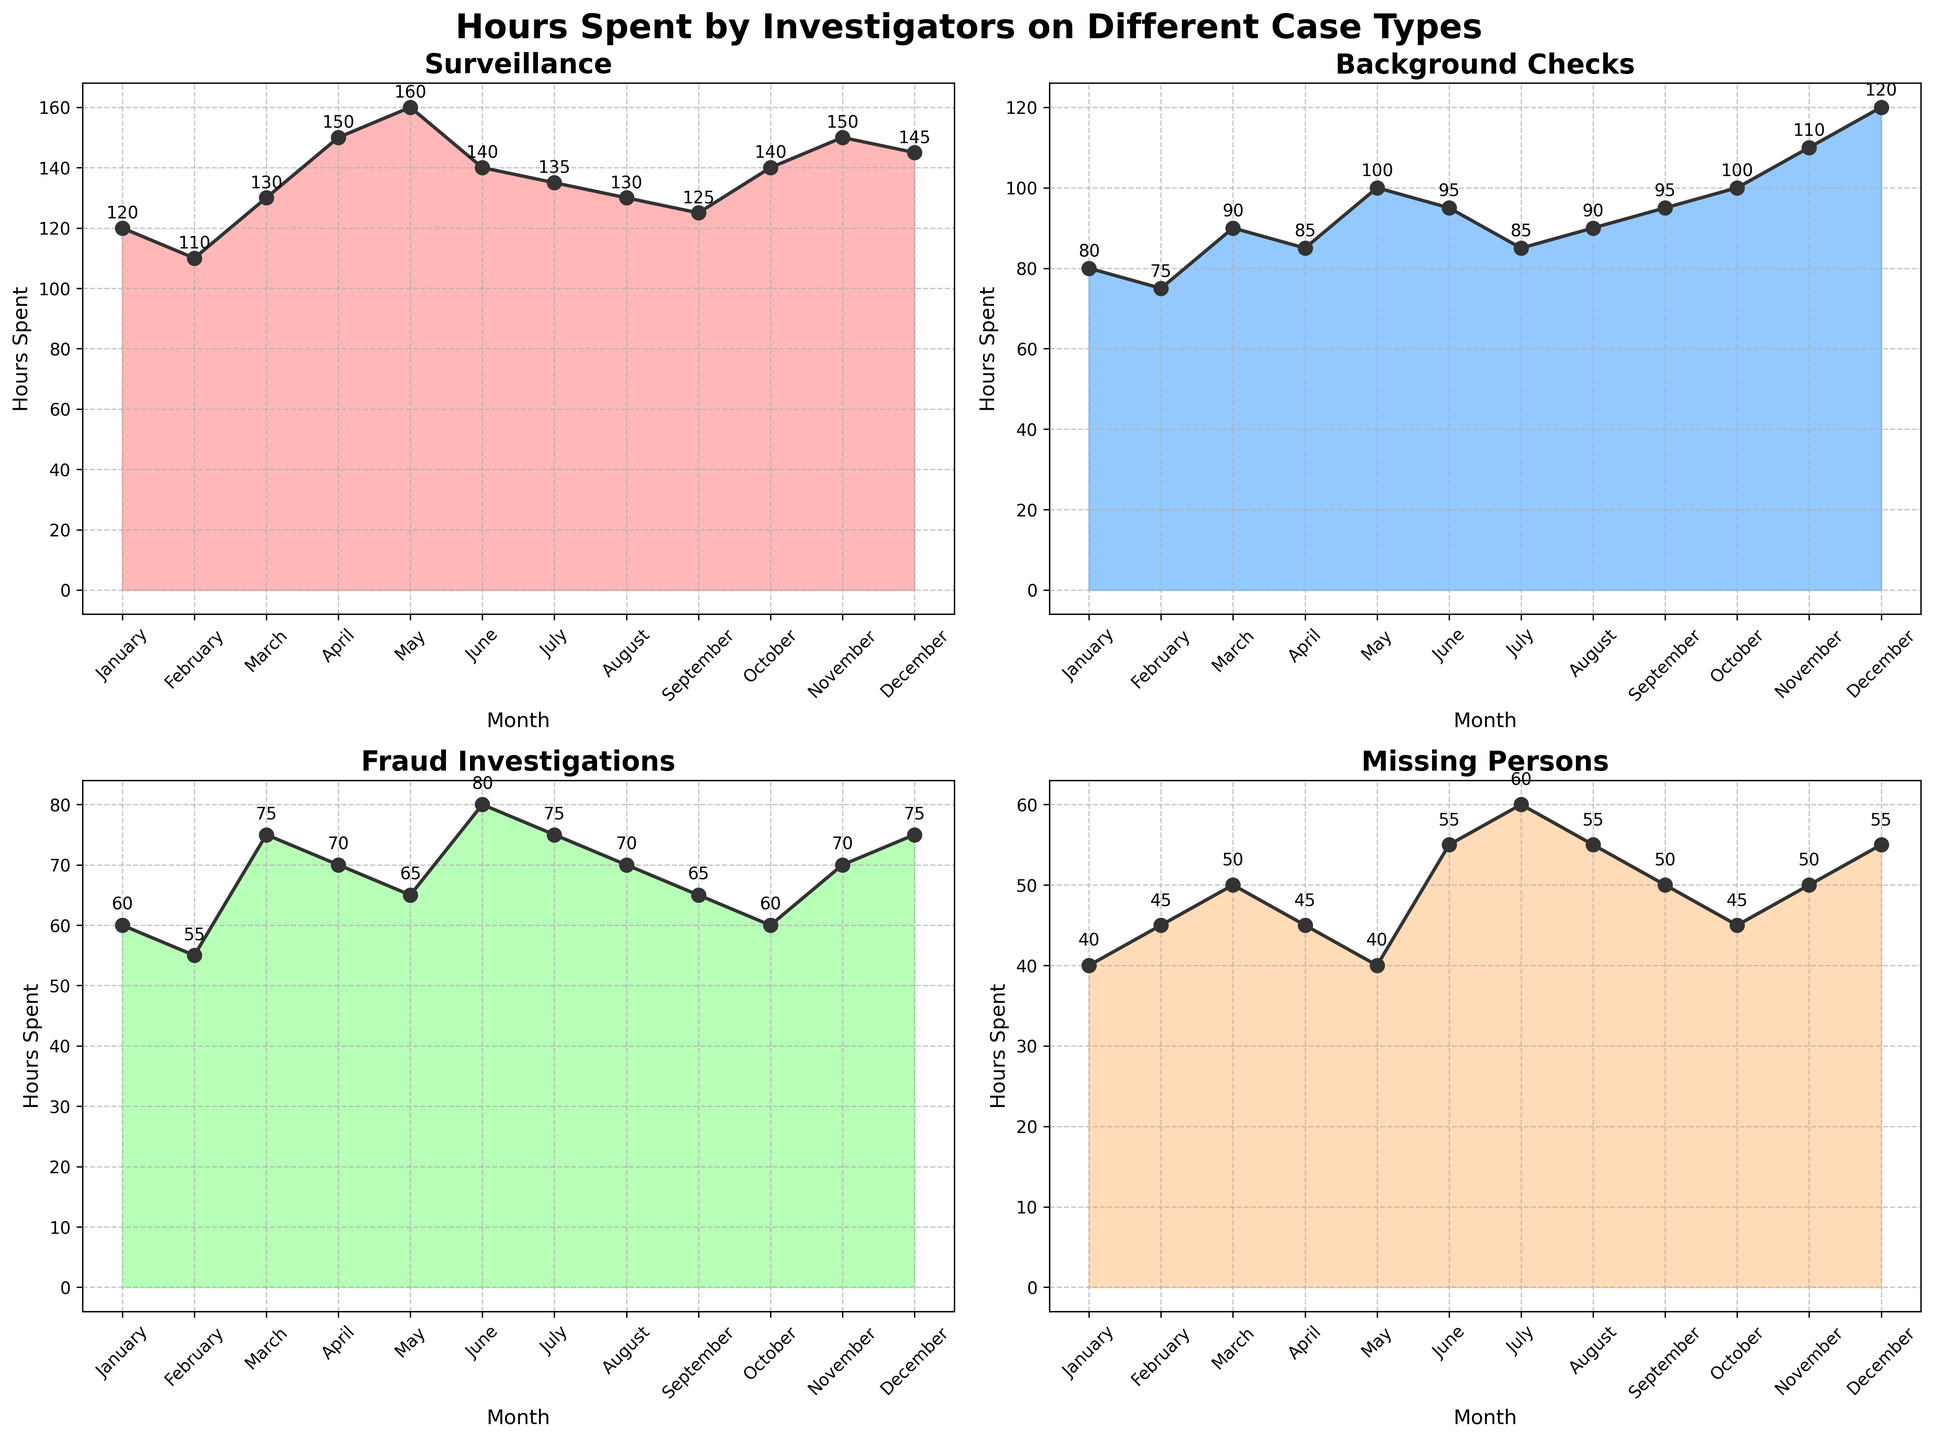Which month had the highest hours spent on Surveillance cases? The Surveillance subplot shows that May had the highest hours spent. By inspecting the peak in the area chart for Surveillance, it's clear that May has the highest value.
Answer: May How many case types are represented in the figure? By counting the titles of each subplot in the figure, we find that there are four case types: Surveillance, Background Checks, Fraud Investigations, and Missing Persons.
Answer: Four What is the overall trend in hours spent on Fraud Investigations throughout the year? By observing the area chart for Fraud Investigations, the trend fluctuates with two prominent peaks in March and June followed by more stable lower values towards the end of the year. Overall, there's no clear trend of increase or decrease.
Answer: Fluctuating Which case type had the least hours spent in January? Comparing the January values across all the subplots, Missing Persons had the least hours spent with 40 hours.
Answer: Missing Persons What is the difference in hours spent on Background Checks between January and December? Referring to the Background Checks subplot, the value in January is 80, and in December is 120. The difference is calculated as 120 - 80 = 40.
Answer: 40 For which case type does the hours spent most steadily increase over the months? By examining the slopes of all four subplots, the Background Checks subplot shows a more steady increase, particularly in the later months, than other case types.
Answer: Background Checks How did the hours spent on Missing Persons cases change from February to March? In the Missing Persons subplot, from February (45 hours) to March (50 hours), the hours spent increased by 5 hours.
Answer: Increased by 5 hours Which case type shows a notable dip in hours spent during the middle of the year? Observing the trends in each subplot, Surveillance shows a notable dip during June and July.
Answer: Surveillance How many data points are shown in each subplot? Each subplot represents monthly data for a year, so there are 12 data points in each subplot.
Answer: 12 During which month were the hours spent on Fraud Investigations the lowest? In the Fraud Investigations subplot, February shows the lowest value with 55 hours.
Answer: February 